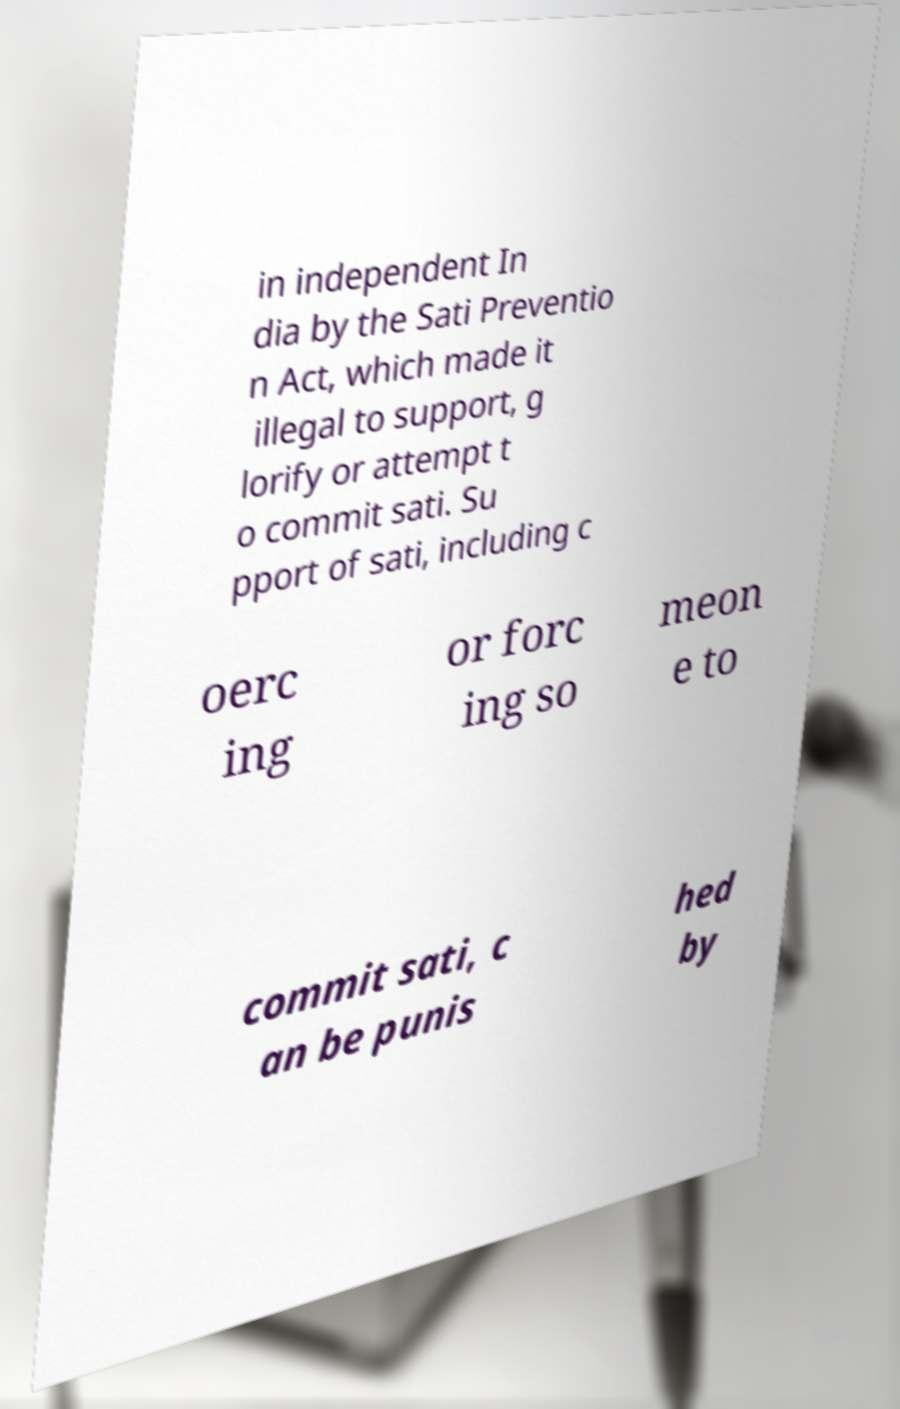Can you read and provide the text displayed in the image?This photo seems to have some interesting text. Can you extract and type it out for me? in independent In dia by the Sati Preventio n Act, which made it illegal to support, g lorify or attempt t o commit sati. Su pport of sati, including c oerc ing or forc ing so meon e to commit sati, c an be punis hed by 